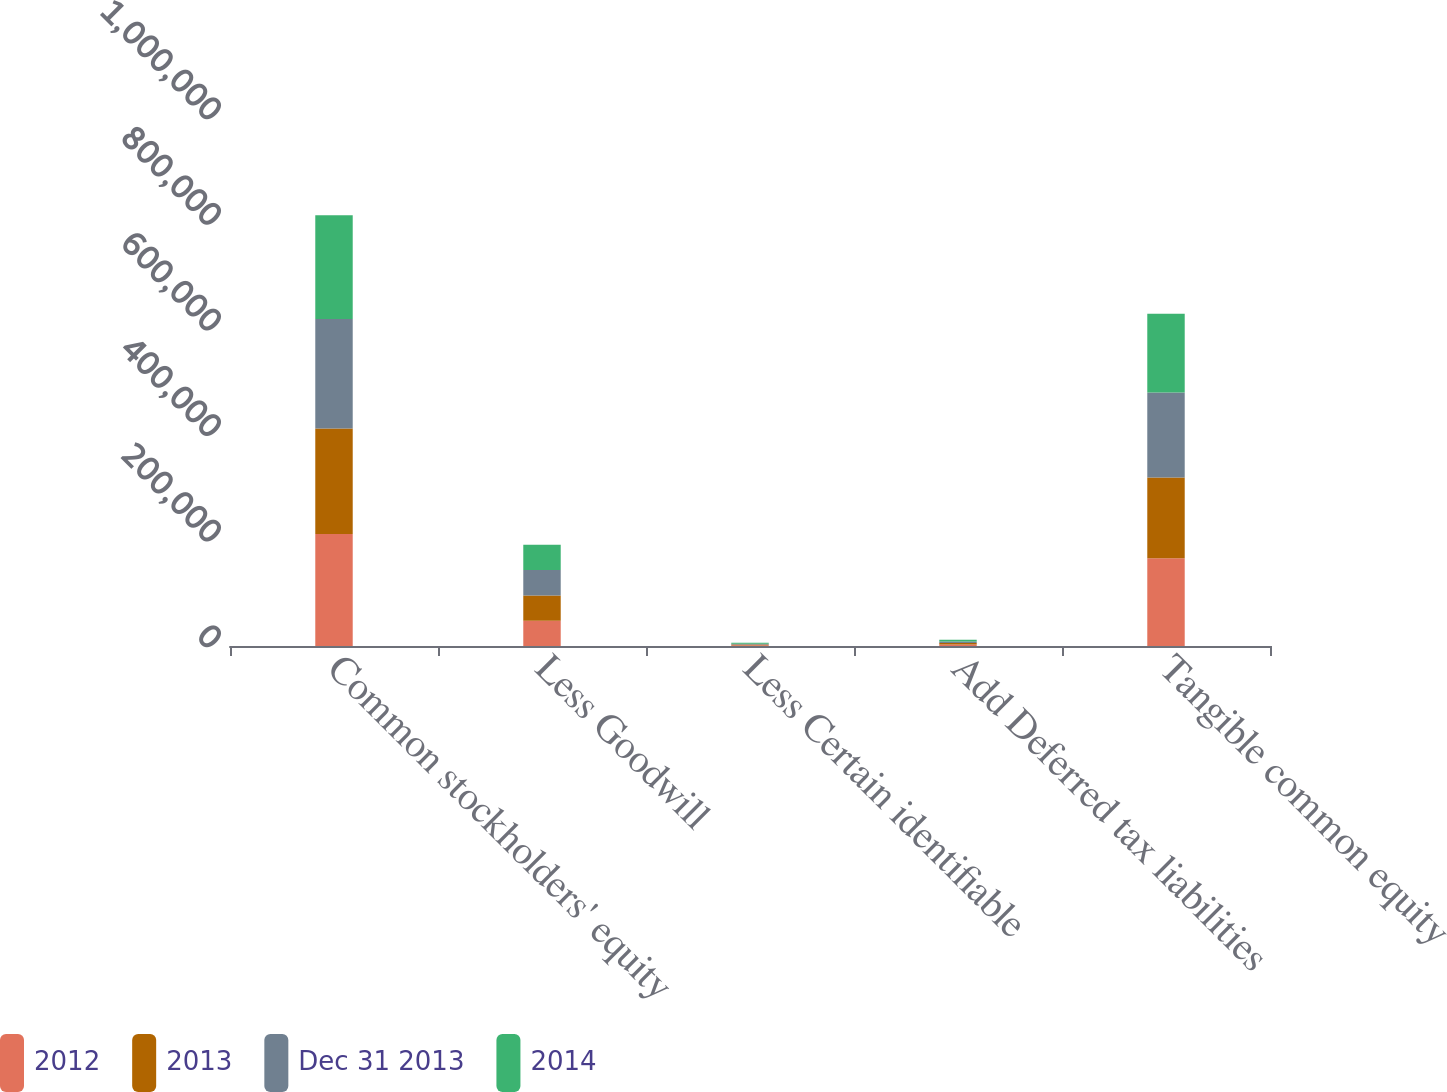<chart> <loc_0><loc_0><loc_500><loc_500><stacked_bar_chart><ecel><fcel>Common stockholders' equity<fcel>Less Goodwill<fcel>Less Certain identifiable<fcel>Add Deferred tax liabilities<fcel>Tangible common equity<nl><fcel>2012<fcel>212002<fcel>47647<fcel>1192<fcel>2853<fcel>166016<nl><fcel>2013<fcel>200020<fcel>48081<fcel>1618<fcel>2953<fcel>153274<nl><fcel>Dec 31 2013<fcel>207400<fcel>48029<fcel>1378<fcel>2950<fcel>160943<nl><fcel>2014<fcel>196409<fcel>48102<fcel>1950<fcel>2885<fcel>149242<nl></chart> 